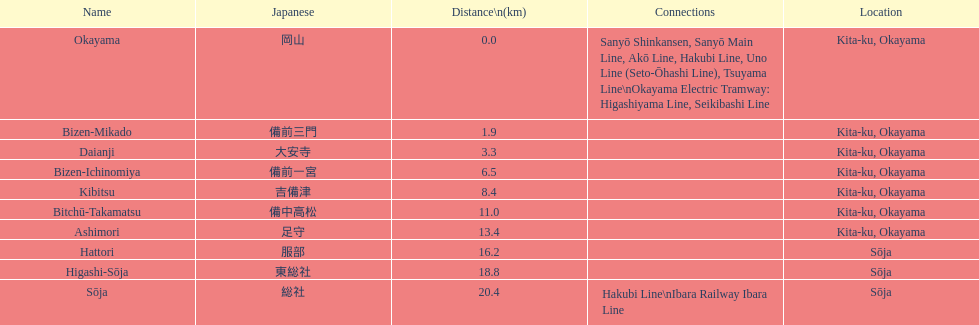How many station are located in kita-ku, okayama? 7. 